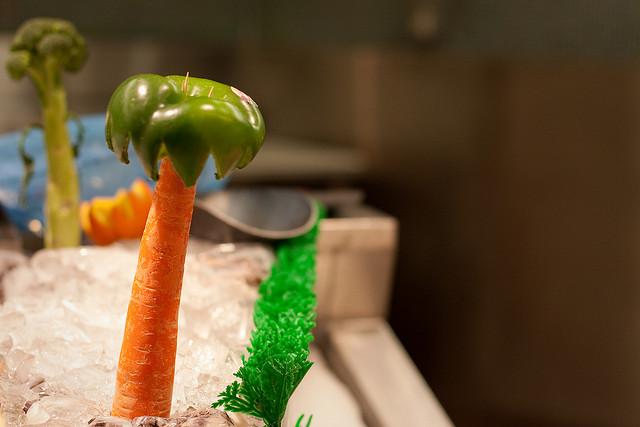Is someone dreaming of a tropical paradise?
Concise answer only. Yes. Is this a real tree?
Concise answer only. No. What vegetable is shown?
Be succinct. Carrot. 